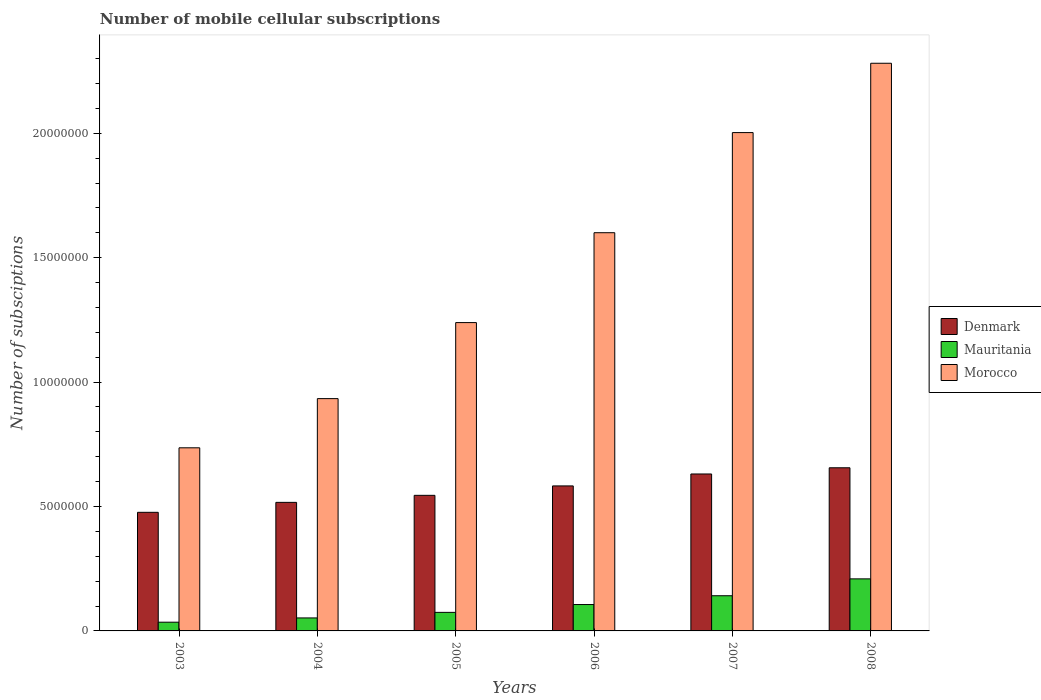How many different coloured bars are there?
Your response must be concise. 3. How many groups of bars are there?
Your response must be concise. 6. Are the number of bars per tick equal to the number of legend labels?
Keep it short and to the point. Yes. Are the number of bars on each tick of the X-axis equal?
Provide a succinct answer. Yes. How many bars are there on the 1st tick from the left?
Offer a very short reply. 3. What is the label of the 2nd group of bars from the left?
Your answer should be compact. 2004. What is the number of mobile cellular subscriptions in Denmark in 2008?
Provide a short and direct response. 6.56e+06. Across all years, what is the maximum number of mobile cellular subscriptions in Mauritania?
Provide a short and direct response. 2.09e+06. Across all years, what is the minimum number of mobile cellular subscriptions in Denmark?
Your answer should be compact. 4.77e+06. In which year was the number of mobile cellular subscriptions in Mauritania minimum?
Your response must be concise. 2003. What is the total number of mobile cellular subscriptions in Mauritania in the graph?
Ensure brevity in your answer.  6.19e+06. What is the difference between the number of mobile cellular subscriptions in Morocco in 2003 and that in 2008?
Your answer should be very brief. -1.55e+07. What is the difference between the number of mobile cellular subscriptions in Morocco in 2008 and the number of mobile cellular subscriptions in Denmark in 2006?
Your response must be concise. 1.70e+07. What is the average number of mobile cellular subscriptions in Denmark per year?
Your response must be concise. 5.68e+06. In the year 2004, what is the difference between the number of mobile cellular subscriptions in Mauritania and number of mobile cellular subscriptions in Denmark?
Provide a succinct answer. -4.64e+06. What is the ratio of the number of mobile cellular subscriptions in Morocco in 2005 to that in 2008?
Ensure brevity in your answer.  0.54. Is the number of mobile cellular subscriptions in Morocco in 2004 less than that in 2006?
Offer a very short reply. Yes. Is the difference between the number of mobile cellular subscriptions in Mauritania in 2003 and 2006 greater than the difference between the number of mobile cellular subscriptions in Denmark in 2003 and 2006?
Ensure brevity in your answer.  Yes. What is the difference between the highest and the second highest number of mobile cellular subscriptions in Denmark?
Give a very brief answer. 2.49e+05. What is the difference between the highest and the lowest number of mobile cellular subscriptions in Morocco?
Your response must be concise. 1.55e+07. Is the sum of the number of mobile cellular subscriptions in Morocco in 2006 and 2007 greater than the maximum number of mobile cellular subscriptions in Mauritania across all years?
Ensure brevity in your answer.  Yes. What does the 2nd bar from the left in 2006 represents?
Offer a very short reply. Mauritania. What does the 1st bar from the right in 2008 represents?
Your answer should be compact. Morocco. Is it the case that in every year, the sum of the number of mobile cellular subscriptions in Denmark and number of mobile cellular subscriptions in Morocco is greater than the number of mobile cellular subscriptions in Mauritania?
Your answer should be compact. Yes. Are all the bars in the graph horizontal?
Provide a succinct answer. No. Does the graph contain any zero values?
Your answer should be compact. No. Does the graph contain grids?
Ensure brevity in your answer.  No. Where does the legend appear in the graph?
Ensure brevity in your answer.  Center right. How many legend labels are there?
Your answer should be compact. 3. How are the legend labels stacked?
Give a very brief answer. Vertical. What is the title of the graph?
Your answer should be very brief. Number of mobile cellular subscriptions. Does "Faeroe Islands" appear as one of the legend labels in the graph?
Offer a very short reply. No. What is the label or title of the Y-axis?
Provide a short and direct response. Number of subsciptions. What is the Number of subsciptions of Denmark in 2003?
Your answer should be very brief. 4.77e+06. What is the Number of subsciptions in Mauritania in 2003?
Keep it short and to the point. 3.51e+05. What is the Number of subsciptions in Morocco in 2003?
Give a very brief answer. 7.36e+06. What is the Number of subsciptions in Denmark in 2004?
Give a very brief answer. 5.17e+06. What is the Number of subsciptions of Mauritania in 2004?
Give a very brief answer. 5.22e+05. What is the Number of subsciptions in Morocco in 2004?
Offer a terse response. 9.34e+06. What is the Number of subsciptions in Denmark in 2005?
Make the answer very short. 5.45e+06. What is the Number of subsciptions of Mauritania in 2005?
Your answer should be very brief. 7.46e+05. What is the Number of subsciptions of Morocco in 2005?
Ensure brevity in your answer.  1.24e+07. What is the Number of subsciptions in Denmark in 2006?
Provide a short and direct response. 5.83e+06. What is the Number of subsciptions of Mauritania in 2006?
Make the answer very short. 1.06e+06. What is the Number of subsciptions in Morocco in 2006?
Make the answer very short. 1.60e+07. What is the Number of subsciptions in Denmark in 2007?
Keep it short and to the point. 6.31e+06. What is the Number of subsciptions of Mauritania in 2007?
Your answer should be compact. 1.41e+06. What is the Number of subsciptions of Morocco in 2007?
Provide a succinct answer. 2.00e+07. What is the Number of subsciptions in Denmark in 2008?
Your answer should be very brief. 6.56e+06. What is the Number of subsciptions of Mauritania in 2008?
Provide a succinct answer. 2.09e+06. What is the Number of subsciptions in Morocco in 2008?
Offer a terse response. 2.28e+07. Across all years, what is the maximum Number of subsciptions of Denmark?
Give a very brief answer. 6.56e+06. Across all years, what is the maximum Number of subsciptions in Mauritania?
Your response must be concise. 2.09e+06. Across all years, what is the maximum Number of subsciptions of Morocco?
Offer a terse response. 2.28e+07. Across all years, what is the minimum Number of subsciptions of Denmark?
Offer a terse response. 4.77e+06. Across all years, what is the minimum Number of subsciptions in Mauritania?
Ensure brevity in your answer.  3.51e+05. Across all years, what is the minimum Number of subsciptions of Morocco?
Make the answer very short. 7.36e+06. What is the total Number of subsciptions in Denmark in the graph?
Make the answer very short. 3.41e+07. What is the total Number of subsciptions of Mauritania in the graph?
Your answer should be very brief. 6.19e+06. What is the total Number of subsciptions of Morocco in the graph?
Your response must be concise. 8.79e+07. What is the difference between the Number of subsciptions of Denmark in 2003 and that in 2004?
Give a very brief answer. -4.00e+05. What is the difference between the Number of subsciptions of Mauritania in 2003 and that in 2004?
Give a very brief answer. -1.71e+05. What is the difference between the Number of subsciptions of Morocco in 2003 and that in 2004?
Your response must be concise. -1.98e+06. What is the difference between the Number of subsciptions in Denmark in 2003 and that in 2005?
Keep it short and to the point. -6.82e+05. What is the difference between the Number of subsciptions in Mauritania in 2003 and that in 2005?
Your answer should be very brief. -3.95e+05. What is the difference between the Number of subsciptions in Morocco in 2003 and that in 2005?
Give a very brief answer. -5.03e+06. What is the difference between the Number of subsciptions of Denmark in 2003 and that in 2006?
Offer a very short reply. -1.06e+06. What is the difference between the Number of subsciptions of Mauritania in 2003 and that in 2006?
Offer a very short reply. -7.09e+05. What is the difference between the Number of subsciptions of Morocco in 2003 and that in 2006?
Keep it short and to the point. -8.64e+06. What is the difference between the Number of subsciptions in Denmark in 2003 and that in 2007?
Your response must be concise. -1.54e+06. What is the difference between the Number of subsciptions in Mauritania in 2003 and that in 2007?
Your answer should be very brief. -1.06e+06. What is the difference between the Number of subsciptions of Morocco in 2003 and that in 2007?
Your answer should be compact. -1.27e+07. What is the difference between the Number of subsciptions in Denmark in 2003 and that in 2008?
Provide a short and direct response. -1.79e+06. What is the difference between the Number of subsciptions of Mauritania in 2003 and that in 2008?
Ensure brevity in your answer.  -1.74e+06. What is the difference between the Number of subsciptions of Morocco in 2003 and that in 2008?
Provide a succinct answer. -1.55e+07. What is the difference between the Number of subsciptions in Denmark in 2004 and that in 2005?
Your answer should be compact. -2.82e+05. What is the difference between the Number of subsciptions of Mauritania in 2004 and that in 2005?
Offer a very short reply. -2.23e+05. What is the difference between the Number of subsciptions in Morocco in 2004 and that in 2005?
Offer a terse response. -3.06e+06. What is the difference between the Number of subsciptions of Denmark in 2004 and that in 2006?
Provide a short and direct response. -6.61e+05. What is the difference between the Number of subsciptions of Mauritania in 2004 and that in 2006?
Ensure brevity in your answer.  -5.38e+05. What is the difference between the Number of subsciptions of Morocco in 2004 and that in 2006?
Keep it short and to the point. -6.67e+06. What is the difference between the Number of subsciptions of Denmark in 2004 and that in 2007?
Your answer should be very brief. -1.14e+06. What is the difference between the Number of subsciptions in Mauritania in 2004 and that in 2007?
Your response must be concise. -8.92e+05. What is the difference between the Number of subsciptions of Morocco in 2004 and that in 2007?
Your response must be concise. -1.07e+07. What is the difference between the Number of subsciptions in Denmark in 2004 and that in 2008?
Keep it short and to the point. -1.39e+06. What is the difference between the Number of subsciptions of Mauritania in 2004 and that in 2008?
Provide a short and direct response. -1.57e+06. What is the difference between the Number of subsciptions in Morocco in 2004 and that in 2008?
Provide a short and direct response. -1.35e+07. What is the difference between the Number of subsciptions in Denmark in 2005 and that in 2006?
Ensure brevity in your answer.  -3.79e+05. What is the difference between the Number of subsciptions in Mauritania in 2005 and that in 2006?
Ensure brevity in your answer.  -3.15e+05. What is the difference between the Number of subsciptions of Morocco in 2005 and that in 2006?
Provide a succinct answer. -3.61e+06. What is the difference between the Number of subsciptions of Denmark in 2005 and that in 2007?
Give a very brief answer. -8.59e+05. What is the difference between the Number of subsciptions of Mauritania in 2005 and that in 2007?
Your response must be concise. -6.68e+05. What is the difference between the Number of subsciptions in Morocco in 2005 and that in 2007?
Your response must be concise. -7.64e+06. What is the difference between the Number of subsciptions in Denmark in 2005 and that in 2008?
Your response must be concise. -1.11e+06. What is the difference between the Number of subsciptions in Mauritania in 2005 and that in 2008?
Make the answer very short. -1.35e+06. What is the difference between the Number of subsciptions in Morocco in 2005 and that in 2008?
Provide a short and direct response. -1.04e+07. What is the difference between the Number of subsciptions of Denmark in 2006 and that in 2007?
Your answer should be compact. -4.80e+05. What is the difference between the Number of subsciptions of Mauritania in 2006 and that in 2007?
Provide a succinct answer. -3.54e+05. What is the difference between the Number of subsciptions in Morocco in 2006 and that in 2007?
Offer a terse response. -4.02e+06. What is the difference between the Number of subsciptions in Denmark in 2006 and that in 2008?
Ensure brevity in your answer.  -7.29e+05. What is the difference between the Number of subsciptions in Mauritania in 2006 and that in 2008?
Provide a short and direct response. -1.03e+06. What is the difference between the Number of subsciptions of Morocco in 2006 and that in 2008?
Give a very brief answer. -6.81e+06. What is the difference between the Number of subsciptions of Denmark in 2007 and that in 2008?
Provide a succinct answer. -2.49e+05. What is the difference between the Number of subsciptions in Mauritania in 2007 and that in 2008?
Ensure brevity in your answer.  -6.78e+05. What is the difference between the Number of subsciptions in Morocco in 2007 and that in 2008?
Offer a terse response. -2.79e+06. What is the difference between the Number of subsciptions in Denmark in 2003 and the Number of subsciptions in Mauritania in 2004?
Keep it short and to the point. 4.24e+06. What is the difference between the Number of subsciptions of Denmark in 2003 and the Number of subsciptions of Morocco in 2004?
Offer a terse response. -4.57e+06. What is the difference between the Number of subsciptions of Mauritania in 2003 and the Number of subsciptions of Morocco in 2004?
Keep it short and to the point. -8.99e+06. What is the difference between the Number of subsciptions of Denmark in 2003 and the Number of subsciptions of Mauritania in 2005?
Offer a terse response. 4.02e+06. What is the difference between the Number of subsciptions in Denmark in 2003 and the Number of subsciptions in Morocco in 2005?
Offer a very short reply. -7.63e+06. What is the difference between the Number of subsciptions in Mauritania in 2003 and the Number of subsciptions in Morocco in 2005?
Offer a very short reply. -1.20e+07. What is the difference between the Number of subsciptions of Denmark in 2003 and the Number of subsciptions of Mauritania in 2006?
Provide a succinct answer. 3.71e+06. What is the difference between the Number of subsciptions of Denmark in 2003 and the Number of subsciptions of Morocco in 2006?
Your answer should be compact. -1.12e+07. What is the difference between the Number of subsciptions of Mauritania in 2003 and the Number of subsciptions of Morocco in 2006?
Provide a short and direct response. -1.57e+07. What is the difference between the Number of subsciptions in Denmark in 2003 and the Number of subsciptions in Mauritania in 2007?
Offer a terse response. 3.35e+06. What is the difference between the Number of subsciptions in Denmark in 2003 and the Number of subsciptions in Morocco in 2007?
Your answer should be compact. -1.53e+07. What is the difference between the Number of subsciptions in Mauritania in 2003 and the Number of subsciptions in Morocco in 2007?
Keep it short and to the point. -1.97e+07. What is the difference between the Number of subsciptions of Denmark in 2003 and the Number of subsciptions of Mauritania in 2008?
Keep it short and to the point. 2.68e+06. What is the difference between the Number of subsciptions in Denmark in 2003 and the Number of subsciptions in Morocco in 2008?
Provide a short and direct response. -1.80e+07. What is the difference between the Number of subsciptions in Mauritania in 2003 and the Number of subsciptions in Morocco in 2008?
Offer a very short reply. -2.25e+07. What is the difference between the Number of subsciptions in Denmark in 2004 and the Number of subsciptions in Mauritania in 2005?
Your answer should be very brief. 4.42e+06. What is the difference between the Number of subsciptions in Denmark in 2004 and the Number of subsciptions in Morocco in 2005?
Your answer should be very brief. -7.23e+06. What is the difference between the Number of subsciptions of Mauritania in 2004 and the Number of subsciptions of Morocco in 2005?
Give a very brief answer. -1.19e+07. What is the difference between the Number of subsciptions in Denmark in 2004 and the Number of subsciptions in Mauritania in 2006?
Ensure brevity in your answer.  4.11e+06. What is the difference between the Number of subsciptions of Denmark in 2004 and the Number of subsciptions of Morocco in 2006?
Your answer should be compact. -1.08e+07. What is the difference between the Number of subsciptions in Mauritania in 2004 and the Number of subsciptions in Morocco in 2006?
Your answer should be very brief. -1.55e+07. What is the difference between the Number of subsciptions in Denmark in 2004 and the Number of subsciptions in Mauritania in 2007?
Give a very brief answer. 3.75e+06. What is the difference between the Number of subsciptions in Denmark in 2004 and the Number of subsciptions in Morocco in 2007?
Your response must be concise. -1.49e+07. What is the difference between the Number of subsciptions in Mauritania in 2004 and the Number of subsciptions in Morocco in 2007?
Give a very brief answer. -1.95e+07. What is the difference between the Number of subsciptions in Denmark in 2004 and the Number of subsciptions in Mauritania in 2008?
Offer a terse response. 3.07e+06. What is the difference between the Number of subsciptions in Denmark in 2004 and the Number of subsciptions in Morocco in 2008?
Offer a very short reply. -1.76e+07. What is the difference between the Number of subsciptions of Mauritania in 2004 and the Number of subsciptions of Morocco in 2008?
Make the answer very short. -2.23e+07. What is the difference between the Number of subsciptions in Denmark in 2005 and the Number of subsciptions in Mauritania in 2006?
Offer a terse response. 4.39e+06. What is the difference between the Number of subsciptions of Denmark in 2005 and the Number of subsciptions of Morocco in 2006?
Keep it short and to the point. -1.06e+07. What is the difference between the Number of subsciptions in Mauritania in 2005 and the Number of subsciptions in Morocco in 2006?
Make the answer very short. -1.53e+07. What is the difference between the Number of subsciptions in Denmark in 2005 and the Number of subsciptions in Mauritania in 2007?
Provide a short and direct response. 4.04e+06. What is the difference between the Number of subsciptions in Denmark in 2005 and the Number of subsciptions in Morocco in 2007?
Your answer should be compact. -1.46e+07. What is the difference between the Number of subsciptions of Mauritania in 2005 and the Number of subsciptions of Morocco in 2007?
Make the answer very short. -1.93e+07. What is the difference between the Number of subsciptions in Denmark in 2005 and the Number of subsciptions in Mauritania in 2008?
Your answer should be very brief. 3.36e+06. What is the difference between the Number of subsciptions of Denmark in 2005 and the Number of subsciptions of Morocco in 2008?
Your response must be concise. -1.74e+07. What is the difference between the Number of subsciptions in Mauritania in 2005 and the Number of subsciptions in Morocco in 2008?
Your answer should be compact. -2.21e+07. What is the difference between the Number of subsciptions of Denmark in 2006 and the Number of subsciptions of Mauritania in 2007?
Provide a short and direct response. 4.41e+06. What is the difference between the Number of subsciptions of Denmark in 2006 and the Number of subsciptions of Morocco in 2007?
Keep it short and to the point. -1.42e+07. What is the difference between the Number of subsciptions in Mauritania in 2006 and the Number of subsciptions in Morocco in 2007?
Give a very brief answer. -1.90e+07. What is the difference between the Number of subsciptions in Denmark in 2006 and the Number of subsciptions in Mauritania in 2008?
Keep it short and to the point. 3.74e+06. What is the difference between the Number of subsciptions in Denmark in 2006 and the Number of subsciptions in Morocco in 2008?
Your answer should be very brief. -1.70e+07. What is the difference between the Number of subsciptions in Mauritania in 2006 and the Number of subsciptions in Morocco in 2008?
Make the answer very short. -2.18e+07. What is the difference between the Number of subsciptions in Denmark in 2007 and the Number of subsciptions in Mauritania in 2008?
Provide a short and direct response. 4.22e+06. What is the difference between the Number of subsciptions of Denmark in 2007 and the Number of subsciptions of Morocco in 2008?
Your answer should be compact. -1.65e+07. What is the difference between the Number of subsciptions in Mauritania in 2007 and the Number of subsciptions in Morocco in 2008?
Offer a very short reply. -2.14e+07. What is the average Number of subsciptions in Denmark per year?
Your answer should be compact. 5.68e+06. What is the average Number of subsciptions in Mauritania per year?
Make the answer very short. 1.03e+06. What is the average Number of subsciptions of Morocco per year?
Make the answer very short. 1.47e+07. In the year 2003, what is the difference between the Number of subsciptions of Denmark and Number of subsciptions of Mauritania?
Provide a short and direct response. 4.42e+06. In the year 2003, what is the difference between the Number of subsciptions of Denmark and Number of subsciptions of Morocco?
Give a very brief answer. -2.59e+06. In the year 2003, what is the difference between the Number of subsciptions of Mauritania and Number of subsciptions of Morocco?
Offer a terse response. -7.01e+06. In the year 2004, what is the difference between the Number of subsciptions of Denmark and Number of subsciptions of Mauritania?
Offer a very short reply. 4.64e+06. In the year 2004, what is the difference between the Number of subsciptions of Denmark and Number of subsciptions of Morocco?
Offer a terse response. -4.17e+06. In the year 2004, what is the difference between the Number of subsciptions of Mauritania and Number of subsciptions of Morocco?
Your answer should be compact. -8.81e+06. In the year 2005, what is the difference between the Number of subsciptions in Denmark and Number of subsciptions in Mauritania?
Your answer should be compact. 4.70e+06. In the year 2005, what is the difference between the Number of subsciptions of Denmark and Number of subsciptions of Morocco?
Give a very brief answer. -6.94e+06. In the year 2005, what is the difference between the Number of subsciptions in Mauritania and Number of subsciptions in Morocco?
Your answer should be very brief. -1.16e+07. In the year 2006, what is the difference between the Number of subsciptions of Denmark and Number of subsciptions of Mauritania?
Your answer should be compact. 4.77e+06. In the year 2006, what is the difference between the Number of subsciptions in Denmark and Number of subsciptions in Morocco?
Ensure brevity in your answer.  -1.02e+07. In the year 2006, what is the difference between the Number of subsciptions of Mauritania and Number of subsciptions of Morocco?
Offer a terse response. -1.49e+07. In the year 2007, what is the difference between the Number of subsciptions in Denmark and Number of subsciptions in Mauritania?
Keep it short and to the point. 4.89e+06. In the year 2007, what is the difference between the Number of subsciptions of Denmark and Number of subsciptions of Morocco?
Offer a terse response. -1.37e+07. In the year 2007, what is the difference between the Number of subsciptions in Mauritania and Number of subsciptions in Morocco?
Make the answer very short. -1.86e+07. In the year 2008, what is the difference between the Number of subsciptions of Denmark and Number of subsciptions of Mauritania?
Ensure brevity in your answer.  4.46e+06. In the year 2008, what is the difference between the Number of subsciptions in Denmark and Number of subsciptions in Morocco?
Provide a short and direct response. -1.63e+07. In the year 2008, what is the difference between the Number of subsciptions in Mauritania and Number of subsciptions in Morocco?
Offer a terse response. -2.07e+07. What is the ratio of the Number of subsciptions of Denmark in 2003 to that in 2004?
Provide a succinct answer. 0.92. What is the ratio of the Number of subsciptions in Mauritania in 2003 to that in 2004?
Give a very brief answer. 0.67. What is the ratio of the Number of subsciptions of Morocco in 2003 to that in 2004?
Your answer should be compact. 0.79. What is the ratio of the Number of subsciptions in Denmark in 2003 to that in 2005?
Your answer should be very brief. 0.87. What is the ratio of the Number of subsciptions of Mauritania in 2003 to that in 2005?
Offer a very short reply. 0.47. What is the ratio of the Number of subsciptions of Morocco in 2003 to that in 2005?
Make the answer very short. 0.59. What is the ratio of the Number of subsciptions of Denmark in 2003 to that in 2006?
Make the answer very short. 0.82. What is the ratio of the Number of subsciptions in Mauritania in 2003 to that in 2006?
Make the answer very short. 0.33. What is the ratio of the Number of subsciptions of Morocco in 2003 to that in 2006?
Offer a very short reply. 0.46. What is the ratio of the Number of subsciptions of Denmark in 2003 to that in 2007?
Your response must be concise. 0.76. What is the ratio of the Number of subsciptions in Mauritania in 2003 to that in 2007?
Provide a short and direct response. 0.25. What is the ratio of the Number of subsciptions in Morocco in 2003 to that in 2007?
Keep it short and to the point. 0.37. What is the ratio of the Number of subsciptions of Denmark in 2003 to that in 2008?
Your answer should be very brief. 0.73. What is the ratio of the Number of subsciptions of Mauritania in 2003 to that in 2008?
Make the answer very short. 0.17. What is the ratio of the Number of subsciptions of Morocco in 2003 to that in 2008?
Offer a terse response. 0.32. What is the ratio of the Number of subsciptions in Denmark in 2004 to that in 2005?
Your answer should be very brief. 0.95. What is the ratio of the Number of subsciptions of Mauritania in 2004 to that in 2005?
Provide a succinct answer. 0.7. What is the ratio of the Number of subsciptions in Morocco in 2004 to that in 2005?
Your answer should be compact. 0.75. What is the ratio of the Number of subsciptions of Denmark in 2004 to that in 2006?
Your answer should be very brief. 0.89. What is the ratio of the Number of subsciptions in Mauritania in 2004 to that in 2006?
Offer a terse response. 0.49. What is the ratio of the Number of subsciptions in Morocco in 2004 to that in 2006?
Ensure brevity in your answer.  0.58. What is the ratio of the Number of subsciptions in Denmark in 2004 to that in 2007?
Ensure brevity in your answer.  0.82. What is the ratio of the Number of subsciptions of Mauritania in 2004 to that in 2007?
Make the answer very short. 0.37. What is the ratio of the Number of subsciptions of Morocco in 2004 to that in 2007?
Keep it short and to the point. 0.47. What is the ratio of the Number of subsciptions of Denmark in 2004 to that in 2008?
Offer a very short reply. 0.79. What is the ratio of the Number of subsciptions in Mauritania in 2004 to that in 2008?
Your answer should be compact. 0.25. What is the ratio of the Number of subsciptions in Morocco in 2004 to that in 2008?
Provide a short and direct response. 0.41. What is the ratio of the Number of subsciptions in Denmark in 2005 to that in 2006?
Your answer should be very brief. 0.94. What is the ratio of the Number of subsciptions in Mauritania in 2005 to that in 2006?
Offer a very short reply. 0.7. What is the ratio of the Number of subsciptions in Morocco in 2005 to that in 2006?
Your response must be concise. 0.77. What is the ratio of the Number of subsciptions in Denmark in 2005 to that in 2007?
Provide a succinct answer. 0.86. What is the ratio of the Number of subsciptions in Mauritania in 2005 to that in 2007?
Your answer should be compact. 0.53. What is the ratio of the Number of subsciptions in Morocco in 2005 to that in 2007?
Your answer should be compact. 0.62. What is the ratio of the Number of subsciptions of Denmark in 2005 to that in 2008?
Offer a terse response. 0.83. What is the ratio of the Number of subsciptions of Mauritania in 2005 to that in 2008?
Your answer should be very brief. 0.36. What is the ratio of the Number of subsciptions in Morocco in 2005 to that in 2008?
Offer a very short reply. 0.54. What is the ratio of the Number of subsciptions in Denmark in 2006 to that in 2007?
Your answer should be compact. 0.92. What is the ratio of the Number of subsciptions in Mauritania in 2006 to that in 2007?
Ensure brevity in your answer.  0.75. What is the ratio of the Number of subsciptions in Morocco in 2006 to that in 2007?
Your answer should be very brief. 0.8. What is the ratio of the Number of subsciptions in Denmark in 2006 to that in 2008?
Offer a terse response. 0.89. What is the ratio of the Number of subsciptions in Mauritania in 2006 to that in 2008?
Make the answer very short. 0.51. What is the ratio of the Number of subsciptions of Morocco in 2006 to that in 2008?
Provide a succinct answer. 0.7. What is the ratio of the Number of subsciptions in Denmark in 2007 to that in 2008?
Make the answer very short. 0.96. What is the ratio of the Number of subsciptions of Mauritania in 2007 to that in 2008?
Provide a short and direct response. 0.68. What is the ratio of the Number of subsciptions in Morocco in 2007 to that in 2008?
Your answer should be compact. 0.88. What is the difference between the highest and the second highest Number of subsciptions in Denmark?
Your response must be concise. 2.49e+05. What is the difference between the highest and the second highest Number of subsciptions in Mauritania?
Your answer should be very brief. 6.78e+05. What is the difference between the highest and the second highest Number of subsciptions in Morocco?
Offer a very short reply. 2.79e+06. What is the difference between the highest and the lowest Number of subsciptions of Denmark?
Your answer should be very brief. 1.79e+06. What is the difference between the highest and the lowest Number of subsciptions in Mauritania?
Give a very brief answer. 1.74e+06. What is the difference between the highest and the lowest Number of subsciptions in Morocco?
Ensure brevity in your answer.  1.55e+07. 